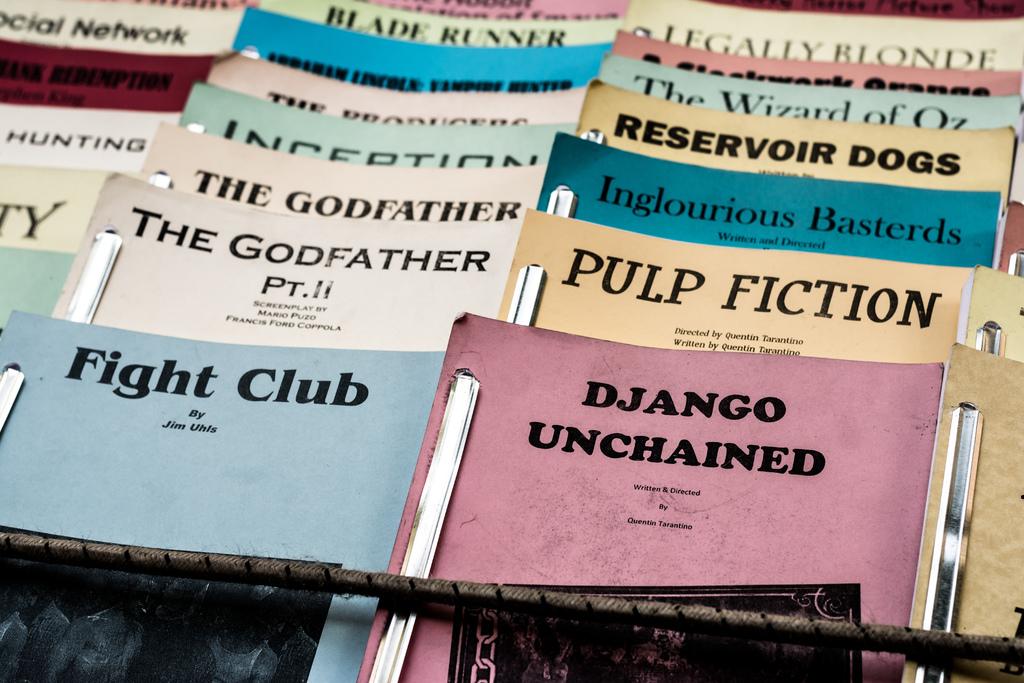Are these movies?
Provide a short and direct response. Yes. The is the red book called?
Your answer should be very brief. Django unchained. 